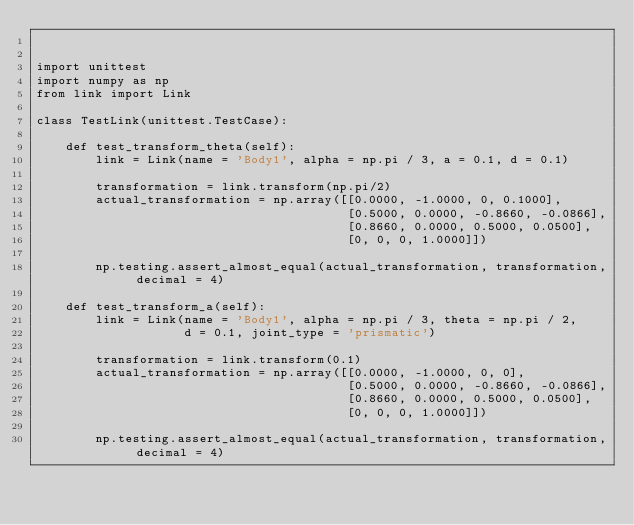Convert code to text. <code><loc_0><loc_0><loc_500><loc_500><_Python_>

import unittest
import numpy as np
from link import Link

class TestLink(unittest.TestCase):

    def test_transform_theta(self):
        link = Link(name = 'Body1', alpha = np.pi / 3, a = 0.1, d = 0.1)

        transformation = link.transform(np.pi/2)
        actual_transformation = np.array([[0.0000, -1.0000, 0, 0.1000],
                                          [0.5000, 0.0000, -0.8660, -0.0866],
                                          [0.8660, 0.0000, 0.5000, 0.0500],
                                          [0, 0, 0, 1.0000]])

        np.testing.assert_almost_equal(actual_transformation, transformation, decimal = 4)

    def test_transform_a(self):
        link = Link(name = 'Body1', alpha = np.pi / 3, theta = np.pi / 2, 
                    d = 0.1, joint_type = 'prismatic')

        transformation = link.transform(0.1)
        actual_transformation = np.array([[0.0000, -1.0000, 0, 0],
                                          [0.5000, 0.0000, -0.8660, -0.0866],
                                          [0.8660, 0.0000, 0.5000, 0.0500],
                                          [0, 0, 0, 1.0000]])

        np.testing.assert_almost_equal(actual_transformation, transformation, decimal = 4)</code> 